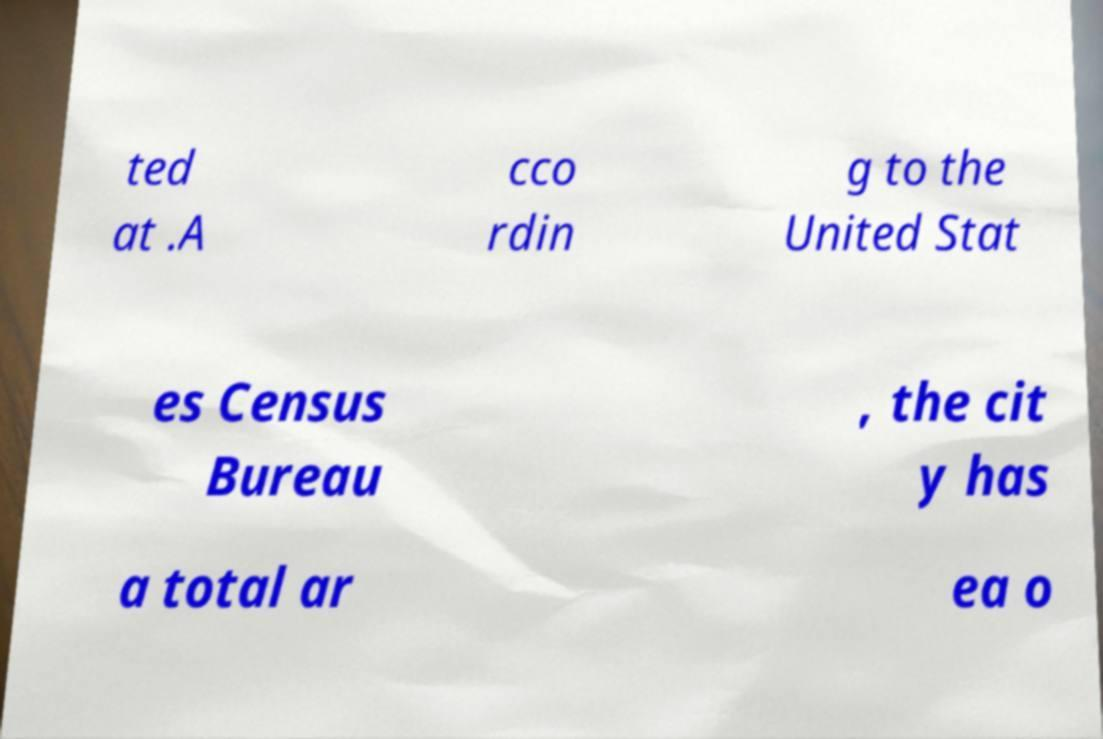Please identify and transcribe the text found in this image. ted at .A cco rdin g to the United Stat es Census Bureau , the cit y has a total ar ea o 